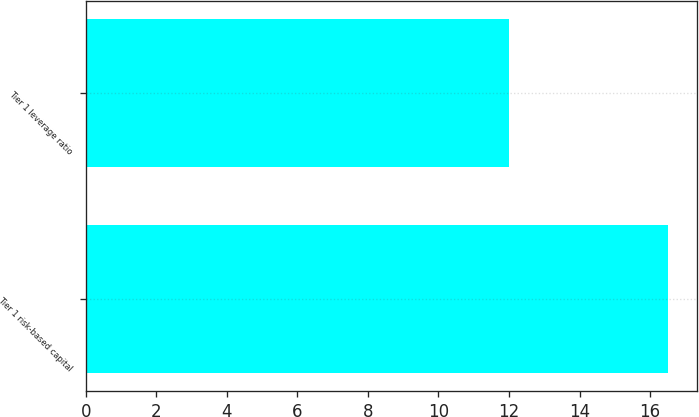Convert chart to OTSL. <chart><loc_0><loc_0><loc_500><loc_500><bar_chart><fcel>Tier 1 risk-based capital<fcel>Tier 1 leverage ratio<nl><fcel>16.5<fcel>12<nl></chart> 